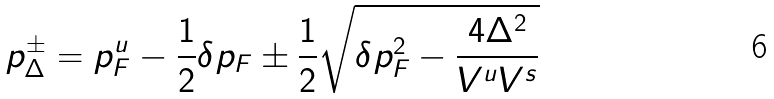Convert formula to latex. <formula><loc_0><loc_0><loc_500><loc_500>p _ { \Delta } ^ { \pm } = p _ { F } ^ { u } - \frac { 1 } { 2 } \delta p _ { F } \pm \frac { 1 } { 2 } \sqrt { \delta p _ { F } ^ { 2 } - \frac { 4 \Delta ^ { 2 } } { V ^ { u } V ^ { s } } }</formula> 